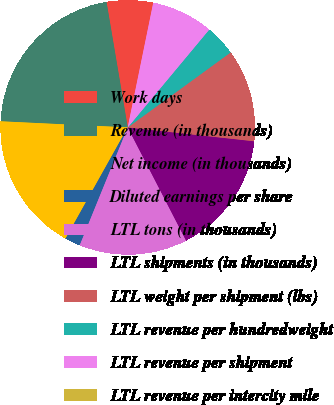<chart> <loc_0><loc_0><loc_500><loc_500><pie_chart><fcel>Work days<fcel>Revenue (in thousands)<fcel>Net income (in thousands)<fcel>Diluted earnings per share<fcel>LTL tons (in thousands)<fcel>LTL shipments (in thousands)<fcel>LTL weight per shipment (lbs)<fcel>LTL revenue per hundredweight<fcel>LTL revenue per shipment<fcel>LTL revenue per intercity mile<nl><fcel>5.88%<fcel>21.57%<fcel>17.65%<fcel>1.96%<fcel>13.73%<fcel>15.69%<fcel>11.76%<fcel>3.92%<fcel>7.84%<fcel>0.0%<nl></chart> 